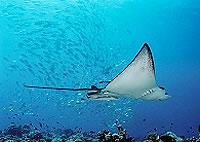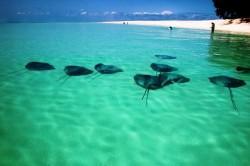The first image is the image on the left, the second image is the image on the right. Given the left and right images, does the statement "The ray in the image on the left is partially under the sand." hold true? Answer yes or no. No. The first image is the image on the left, the second image is the image on the right. Analyze the images presented: Is the assertion "An image shows one stingray, which is partly submerged in sand." valid? Answer yes or no. No. 